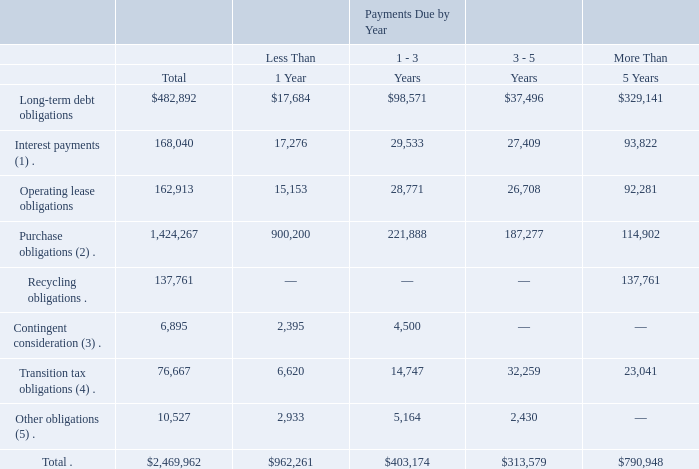Contractual Obligations
The following table presents the payments due by fiscal year for our outstanding contractual obligations as of December 31, 2019 (in thousands):
(1) Includes estimated cash interest to be paid over the remaining terms of the underlying debt. Interest payments are based on fixed and floating rates as of December 31, 2019.
(2) Purchase obligations represent agreements to purchase goods or services, including open purchase orders and contracts with fixed volume commitments, that are noncancelable or cancelable with a significant penalty. Purchase obligations for our long-term supply agreements for the purchase of substrate glass and cover glass represent specified termination penalties, which are up to $430 million in the aggregate under the agreements. Our actual purchases under these supply agreements are expected to be approximately $2.4 billion of substrate glass and $500 million of cover glass.
(3) In connection with business or project acquisitions, we may agree to pay additional amounts to the selling parties upon achievement of certain milestones. See Note 14. “Commitments and Contingencies” to our consolidated financial statements for further information.
(4) Transition tax obligations represent estimated payments for U.S. federal taxes associated with accumulated earnings and profits of our foreign corporate subsidiaries. See Note 18. “Income Taxes” to our consolidated financial statements for further information.
(5) Includes expected letter of credit fees and unused revolver fees.
We have excluded $72.2 million of unrecognized tax benefits from the amounts presented above as the timing of such obligations is uncertain.
What are included in other obligations? Includes expected letter of credit fees and unused revolver fees. Why was $72.2 million of unrecognized tax benefits excluded? We have excluded $72.2 million of unrecognized tax benefits from the amounts presented above as the timing of such obligations is uncertain. What do purchase obligations represent? Purchase obligations represent agreements to purchase goods or services, including open purchase orders and contracts with fixed volume commitments, that are noncancelable or cancelable with a significant penalty. What percentage of the total contractual obligations is made up of total purchase obligations?
Answer scale should be: percent. 1,424,267/2,469,962 
Answer: 57.66. What percentage of the total contractual obligations is made up of total long-term debt obligations?
Answer scale should be: percent. 482,892/2,469,962 
Answer: 19.55. What difference between total interest payments and total operating lease obligations?
Answer scale should be: thousand. 168,040 - 162,913 
Answer: 5127. 